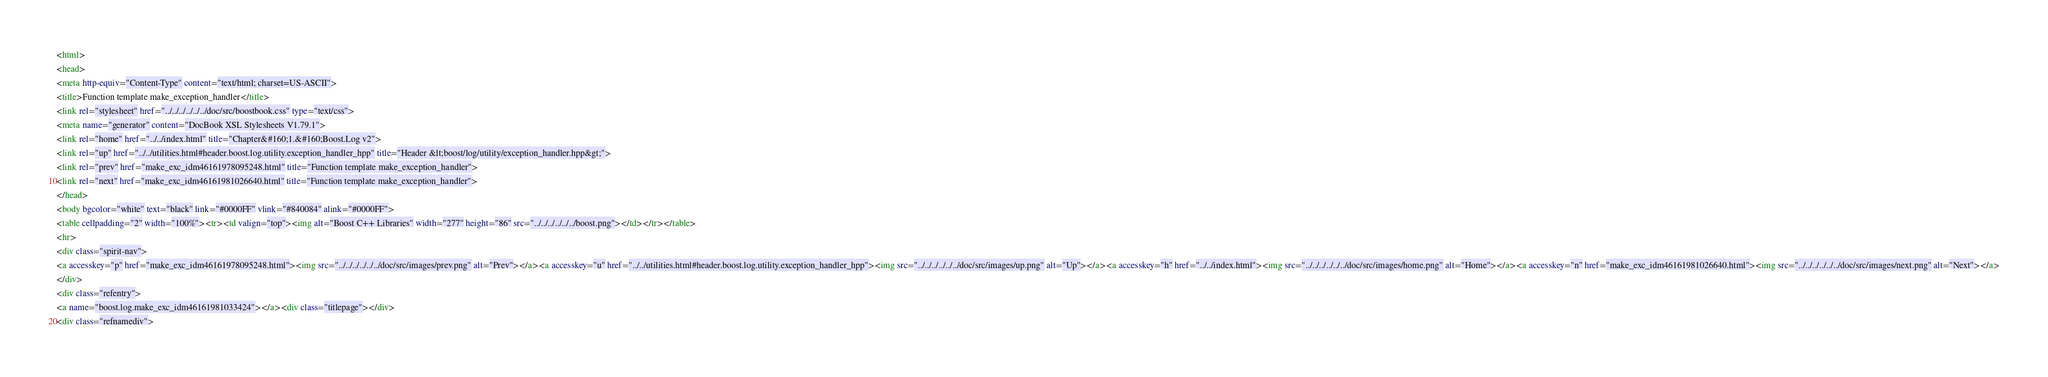Convert code to text. <code><loc_0><loc_0><loc_500><loc_500><_HTML_><html>
<head>
<meta http-equiv="Content-Type" content="text/html; charset=US-ASCII">
<title>Function template make_exception_handler</title>
<link rel="stylesheet" href="../../../../../../doc/src/boostbook.css" type="text/css">
<meta name="generator" content="DocBook XSL Stylesheets V1.79.1">
<link rel="home" href="../../index.html" title="Chapter&#160;1.&#160;Boost.Log v2">
<link rel="up" href="../../utilities.html#header.boost.log.utility.exception_handler_hpp" title="Header &lt;boost/log/utility/exception_handler.hpp&gt;">
<link rel="prev" href="make_exc_idm46161978095248.html" title="Function template make_exception_handler">
<link rel="next" href="make_exc_idm46161981026640.html" title="Function template make_exception_handler">
</head>
<body bgcolor="white" text="black" link="#0000FF" vlink="#840084" alink="#0000FF">
<table cellpadding="2" width="100%"><tr><td valign="top"><img alt="Boost C++ Libraries" width="277" height="86" src="../../../../../../boost.png"></td></tr></table>
<hr>
<div class="spirit-nav">
<a accesskey="p" href="make_exc_idm46161978095248.html"><img src="../../../../../../doc/src/images/prev.png" alt="Prev"></a><a accesskey="u" href="../../utilities.html#header.boost.log.utility.exception_handler_hpp"><img src="../../../../../../doc/src/images/up.png" alt="Up"></a><a accesskey="h" href="../../index.html"><img src="../../../../../../doc/src/images/home.png" alt="Home"></a><a accesskey="n" href="make_exc_idm46161981026640.html"><img src="../../../../../../doc/src/images/next.png" alt="Next"></a>
</div>
<div class="refentry">
<a name="boost.log.make_exc_idm46161981033424"></a><div class="titlepage"></div>
<div class="refnamediv"></code> 